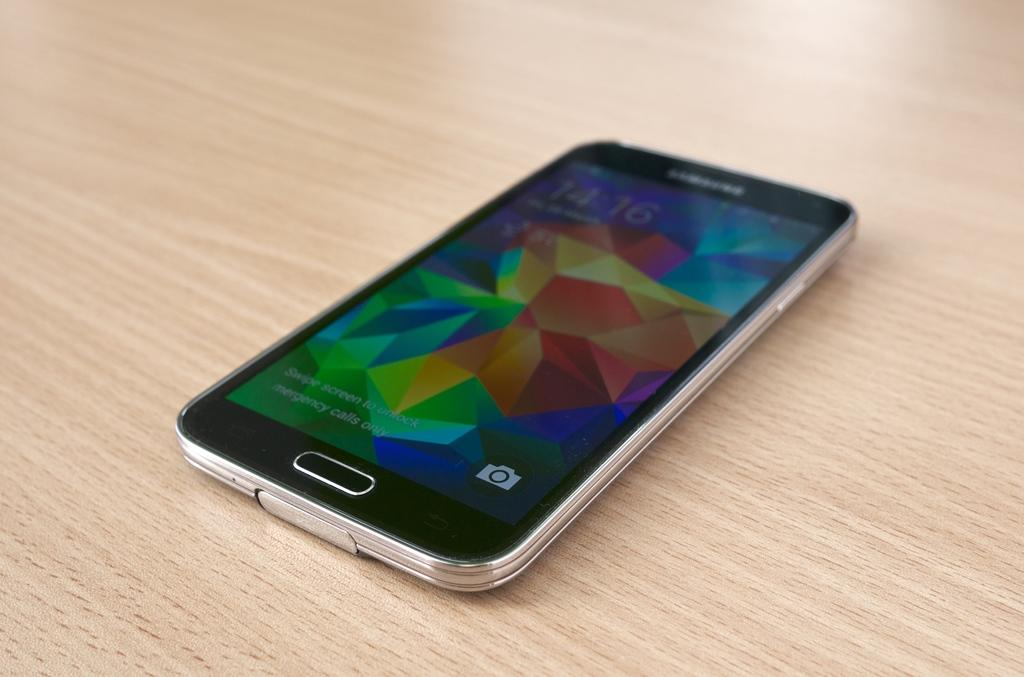<image>
Create a compact narrative representing the image presented. The phone can only make emergency calls until unlocked by swiping. 